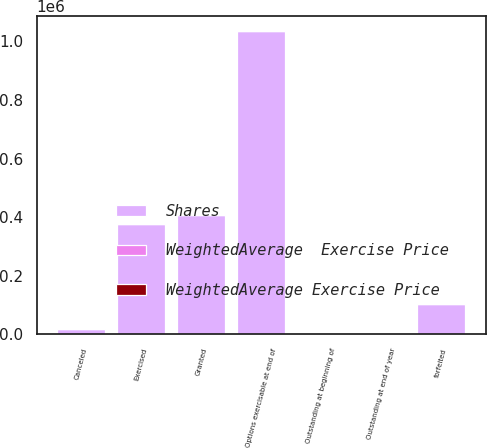Convert chart. <chart><loc_0><loc_0><loc_500><loc_500><stacked_bar_chart><ecel><fcel>Outstanding at beginning of<fcel>Granted<fcel>Exercised<fcel>forfeited<fcel>Canceled<fcel>Outstanding at end of year<fcel>Options exercisable at end of<nl><fcel>Shares<fcel>34.07<fcel>408046<fcel>375222<fcel>102481<fcel>17390<fcel>34.07<fcel>1.03528e+06<nl><fcel>WeightedAverage  Exercise Price<fcel>31.04<fcel>43.15<fcel>20.85<fcel>41.29<fcel>46.09<fcel>34.07<fcel>26.49<nl><fcel>WeightedAverage Exercise Price<fcel>21.61<fcel>47.37<fcel>18.64<fcel>24.95<fcel>21.44<fcel>25.37<fcel>19.77<nl></chart> 